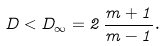Convert formula to latex. <formula><loc_0><loc_0><loc_500><loc_500>D < D _ { \infty } = 2 \, \frac { m + 1 } { m - 1 } .</formula> 